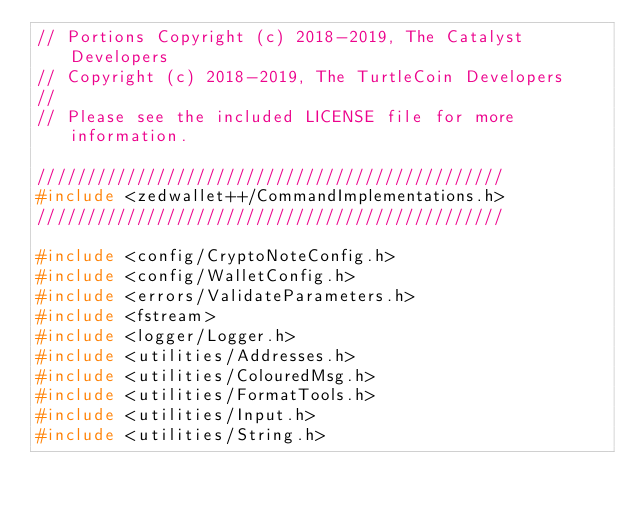<code> <loc_0><loc_0><loc_500><loc_500><_C++_>// Portions Copyright (c) 2018-2019, The Catalyst Developers
// Copyright (c) 2018-2019, The TurtleCoin Developers
//
// Please see the included LICENSE file for more information.

///////////////////////////////////////////////
#include <zedwallet++/CommandImplementations.h>
///////////////////////////////////////////////

#include <config/CryptoNoteConfig.h>
#include <config/WalletConfig.h>
#include <errors/ValidateParameters.h>
#include <fstream>
#include <logger/Logger.h>
#include <utilities/Addresses.h>
#include <utilities/ColouredMsg.h>
#include <utilities/FormatTools.h>
#include <utilities/Input.h>
#include <utilities/String.h></code> 